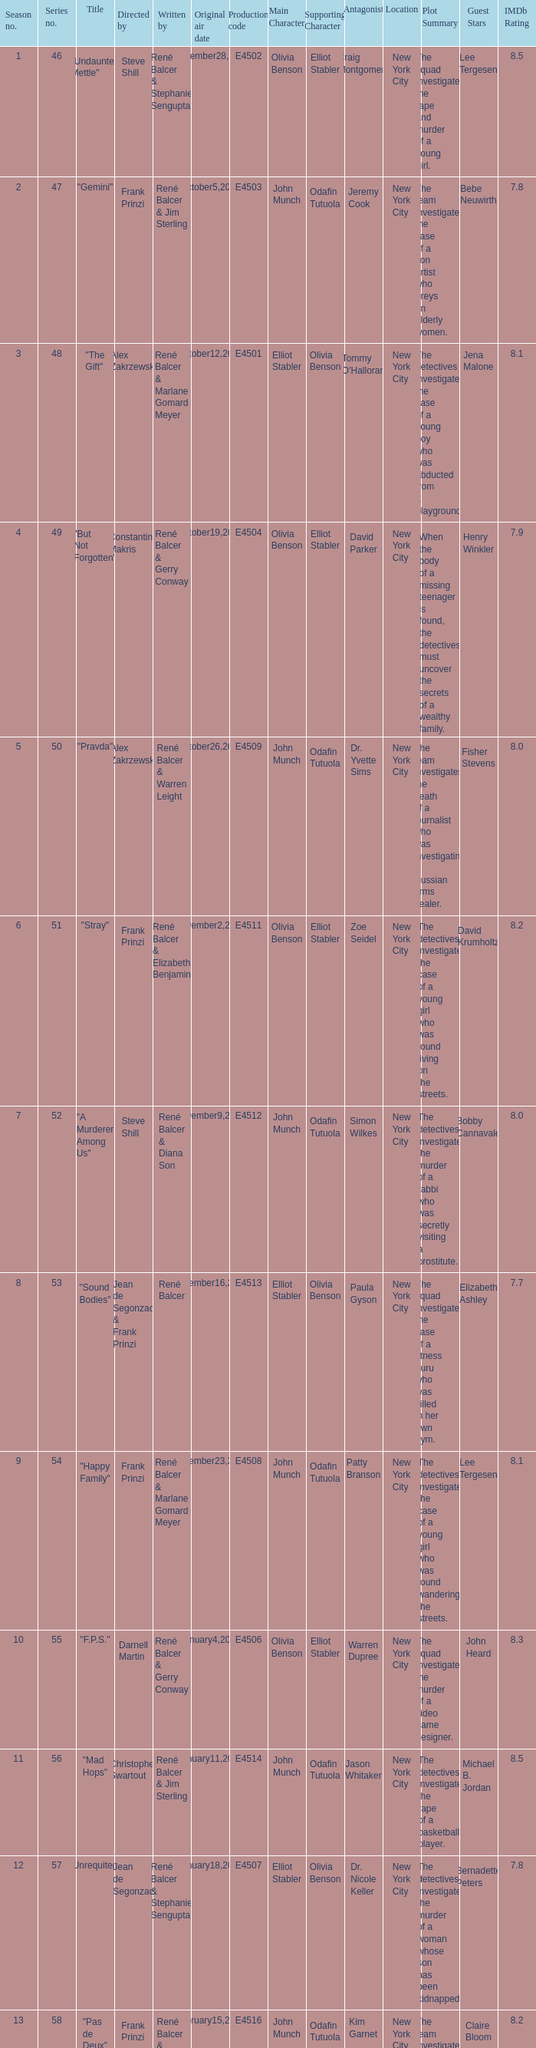What date did "d.a.w." Originally air? May16,2004. Parse the full table. {'header': ['Season no.', 'Series no.', 'Title', 'Directed by', 'Written by', 'Original air date', 'Production code', 'Main Character', 'Supporting Character', 'Antagonist', 'Location', 'Plot Summary', 'Guest Stars', 'IMDb Rating'], 'rows': [['1', '46', '"Undaunted Mettle"', 'Steve Shill', 'René Balcer & Stephanie Sengupta', 'September28,2003', 'E4502', 'Olivia Benson', 'Elliot Stabler', 'Craig Montgomery', 'New York City', 'The squad investigates the rape and murder of a young girl.', 'Lee Tergesen', '8.5'], ['2', '47', '"Gemini"', 'Frank Prinzi', 'René Balcer & Jim Sterling', 'October5,2003', 'E4503', 'John Munch', 'Odafin Tutuola', 'Jeremy Cook', 'New York City', 'The team investigates the case of a con artist who preys on elderly women.', 'Bebe Neuwirth', '7.8'], ['3', '48', '"The Gift"', 'Alex Zakrzewski', 'René Balcer & Marlane Gomard Meyer', 'October12,2003', 'E4501', 'Elliot Stabler', 'Olivia Benson', "Tommy O'Halloran", 'New York City', 'The detectives investigate the case of a young boy who was abducted from a playground.', 'Jena Malone', '8.1'], ['4', '49', '"But Not Forgotten"', 'Constantine Makris', 'René Balcer & Gerry Conway', 'October19,2003', 'E4504', 'Olivia Benson', 'Elliot Stabler', 'David Parker', 'New York City', 'When the body of a missing teenager is found, the detectives must uncover the secrets of a wealthy family.', 'Henry Winkler', '7.9'], ['5', '50', '"Pravda"', 'Alex Zakrzewski', 'René Balcer & Warren Leight', 'October26,2003', 'E4509', 'John Munch', 'Odafin Tutuola', 'Dr. Yvette Sims', 'New York City', 'The team investigates the death of a journalist who was investigating a Russian arms dealer.', 'Fisher Stevens', '8.0'], ['6', '51', '"Stray"', 'Frank Prinzi', 'René Balcer & Elizabeth Benjamin', 'November2,2003', 'E4511', 'Olivia Benson', 'Elliot Stabler', 'Zoe Seidel', 'New York City', 'The detectives investigate the case of a young girl who was found living on the streets.', 'David Krumholtz', '8.2'], ['7', '52', '"A Murderer Among Us"', 'Steve Shill', 'René Balcer & Diana Son', 'November9,2003', 'E4512', 'John Munch', 'Odafin Tutuola', 'Simon Wilkes', 'New York City', 'The detectives investigate the murder of a rabbi who was secretly visiting a prostitute.', 'Bobby Cannavale', '8.0'], ['8', '53', '"Sound Bodies"', 'Jean de Segonzac & Frank Prinzi', 'René Balcer', 'November16,2003', 'E4513', 'Elliot Stabler', 'Olivia Benson', 'Paula Gyson', 'New York City', 'The squad investigates the case of a fitness guru who was killed in her own gym.', 'Elizabeth Ashley', '7.7'], ['9', '54', '"Happy Family"', 'Frank Prinzi', 'René Balcer & Marlane Gomard Meyer', 'November23,2003', 'E4508', 'John Munch', 'Odafin Tutuola', 'Patty Branson', 'New York City', 'The detectives investigate the case of a young girl who was found wandering the streets.', 'Lee Tergesen', '8.1'], ['10', '55', '"F.P.S."', 'Darnell Martin', 'René Balcer & Gerry Conway', 'January4,2004', 'E4506', 'Olivia Benson', 'Elliot Stabler', 'Warren Dupree', 'New York City', 'The squad investigates the murder of a video game designer.', 'John Heard', '8.3'], ['11', '56', '"Mad Hops"', 'Christopher Swartout', 'René Balcer & Jim Sterling', 'January11,2004', 'E4514', 'John Munch', 'Odafin Tutuola', 'Jason Whitaker', 'New York City', 'The detectives investigate the rape of a basketball player.', 'Michael B. Jordan', '8.5'], ['12', '57', '"Unrequited"', 'Jean de Segonzac', 'René Balcer & Stephanie Sengupta', 'January18,2004', 'E4507', 'Elliot Stabler', 'Olivia Benson', 'Dr. Nicole Keller', 'New York City', 'The detectives investigate the murder of a woman whose son has been kidnapped.', 'Bernadette Peters', '7.8'], ['13', '58', '"Pas de Deux"', 'Frank Prinzi', 'René Balcer & Warren Leight', 'February15,2004', 'E4516', 'John Munch', 'Odafin Tutuola', 'Kim Garnet', 'New York City', 'The team investigates the murder of a ballerina.', 'Claire Bloom', '8.2'], ['14', '59', '"Mis-Labeled"', 'Joyce Chopra', 'René Balcer & Elizabeth Benjamin', 'February22,2004', 'E4515', 'Olivia Benson', 'Elliot Stabler', 'Jasper Brisette', 'New York City', 'The detectives investigate the death of a baby who was mislabeled at the hospital.', 'Mischa Barton', '7.9'], ['15', '60', '"Shrink-Wrapped"', 'Jean de Segonzac', 'René Balcer & Diana Son', 'March7,2004', 'E4510', 'John Munch', 'Odafin Tutuola', 'Dr. Rebecca Hendrix', 'New York City', 'The detectives investigate the case of a therapist who was killed in her office.', 'Mary Stuart Masterson', '8.3'], ['16', '61', '"The Saint"', 'Frank Prinzi', 'René Balcer & Marlane Gomard Meyer', 'March14,2004', 'E4517', 'Elliot Stabler', 'Olivia Benson', 'Sister Peg', 'New York City', 'The detectives investigate the rape and murder of a nun.', 'Anne Meara', '7.7'], ['17', '62', '"Conscience"', 'Alex Chapple', 'René Balcer & Gerry Conway', 'March28,2004', 'E4519', 'John Munch', 'Odafin Tutuola', 'Andrew Hingham', 'New York City', 'The team investigates the case of a man who was killed because he continued to speak out against a pedophile priest.', "Michael O'Keefe", '8.5'], ['18', '63', '"Ill-Bred"', 'Steve Shill', 'René Balcer & Jim Sterling', 'April18,2004', 'E4520', 'Olivia Benson', 'Elliot Stabler', 'Josh Lemle', 'New York City', 'The detectives investigate the rape and murder of a young girl who was living on a farm.', 'Marlee Matlin', '8.0'], ['19', '64', '"Fico di Capo"', 'Alex Zakrzewski', 'René Balcer & Stephanie Sengupta', 'May9,2004', 'E4518', 'John Munch', 'Odafin Tutuola', 'Victor Bodine', 'New York City', 'The team investigates the kidnapping of the son of a mob boss.', 'Fred Dalton Thompson', '8.4'], ['20', '65', '"D.A.W."', 'Frank Prinzi', 'René Balcer & Warren Leight', 'May16,2004', 'E4522', 'Elliot Stabler', 'Olivia Benson', 'William Lewis', 'New York City', 'The detectives investigate a case of sexual abuse involving a well-known dentist.', 'Robin Williams', '8.7']]} 